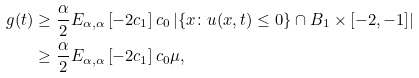<formula> <loc_0><loc_0><loc_500><loc_500>g ( t ) & \geq \frac { \alpha } { 2 } E _ { \alpha , \alpha } \left [ - 2 c _ { 1 } \right ] c _ { 0 } \left | \left \{ x \colon u ( x , t ) \leq 0 \right \} \cap B _ { 1 } \times [ - 2 , - 1 ] \right | \\ & \geq \frac { \alpha } { 2 } E _ { \alpha , \alpha } \left [ - 2 c _ { 1 } \right ] c _ { 0 } \mu ,</formula> 